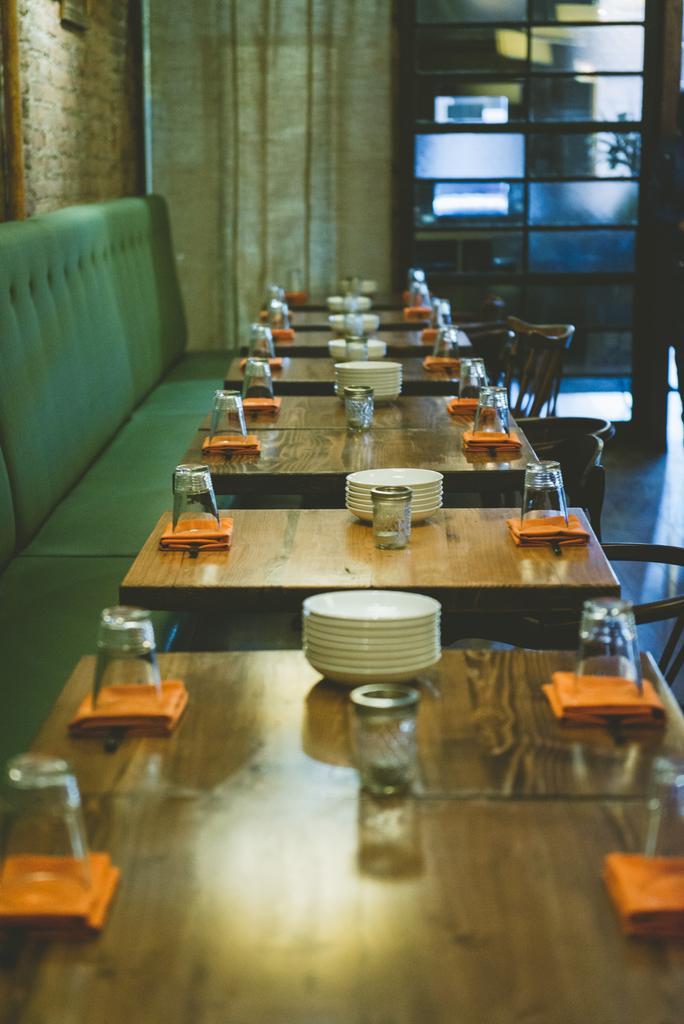Can you describe this image briefly? In this image there is a sofa having tables before it. On top of table there are plates, glasses, napkins and bottle on it. At right side there are few chairs. Background there is a curtain and rack. 